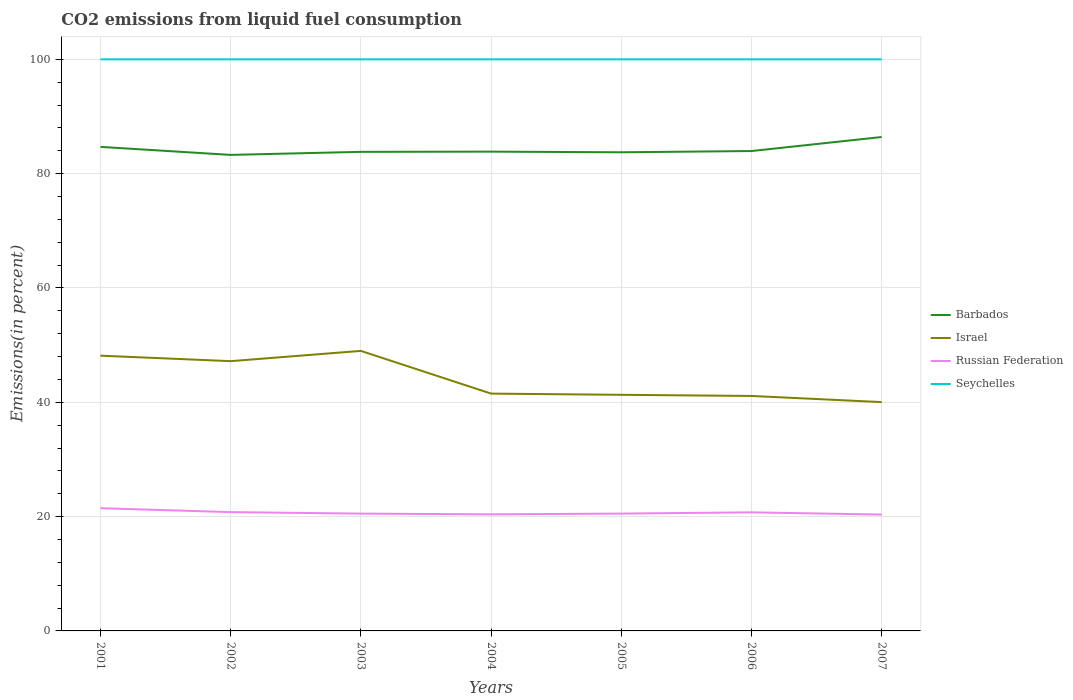Does the line corresponding to Seychelles intersect with the line corresponding to Russian Federation?
Ensure brevity in your answer.  No. Is the number of lines equal to the number of legend labels?
Give a very brief answer. Yes. Across all years, what is the maximum total CO2 emitted in Russian Federation?
Your answer should be very brief. 20.35. What is the total total CO2 emitted in Israel in the graph?
Offer a terse response. 8.12. What is the difference between the highest and the second highest total CO2 emitted in Barbados?
Offer a terse response. 3.13. How many lines are there?
Provide a succinct answer. 4. How many years are there in the graph?
Make the answer very short. 7. Does the graph contain any zero values?
Provide a short and direct response. No. How many legend labels are there?
Keep it short and to the point. 4. What is the title of the graph?
Your answer should be compact. CO2 emissions from liquid fuel consumption. Does "Bangladesh" appear as one of the legend labels in the graph?
Ensure brevity in your answer.  No. What is the label or title of the X-axis?
Give a very brief answer. Years. What is the label or title of the Y-axis?
Your answer should be very brief. Emissions(in percent). What is the Emissions(in percent) in Barbados in 2001?
Give a very brief answer. 84.68. What is the Emissions(in percent) of Israel in 2001?
Offer a terse response. 48.15. What is the Emissions(in percent) of Russian Federation in 2001?
Provide a succinct answer. 21.47. What is the Emissions(in percent) in Seychelles in 2001?
Make the answer very short. 100. What is the Emissions(in percent) in Barbados in 2002?
Give a very brief answer. 83.28. What is the Emissions(in percent) in Israel in 2002?
Ensure brevity in your answer.  47.2. What is the Emissions(in percent) of Russian Federation in 2002?
Offer a terse response. 20.79. What is the Emissions(in percent) of Seychelles in 2002?
Keep it short and to the point. 100. What is the Emissions(in percent) of Barbados in 2003?
Give a very brief answer. 83.82. What is the Emissions(in percent) of Israel in 2003?
Offer a very short reply. 48.99. What is the Emissions(in percent) of Russian Federation in 2003?
Provide a short and direct response. 20.52. What is the Emissions(in percent) of Barbados in 2004?
Provide a short and direct response. 83.85. What is the Emissions(in percent) of Israel in 2004?
Provide a short and direct response. 41.52. What is the Emissions(in percent) in Russian Federation in 2004?
Your answer should be very brief. 20.39. What is the Emissions(in percent) of Seychelles in 2004?
Provide a succinct answer. 100. What is the Emissions(in percent) in Barbados in 2005?
Ensure brevity in your answer.  83.74. What is the Emissions(in percent) in Israel in 2005?
Provide a short and direct response. 41.31. What is the Emissions(in percent) of Russian Federation in 2005?
Your response must be concise. 20.53. What is the Emissions(in percent) of Barbados in 2006?
Provide a succinct answer. 83.96. What is the Emissions(in percent) in Israel in 2006?
Ensure brevity in your answer.  41.11. What is the Emissions(in percent) of Russian Federation in 2006?
Make the answer very short. 20.74. What is the Emissions(in percent) of Seychelles in 2006?
Your response must be concise. 100. What is the Emissions(in percent) in Barbados in 2007?
Your answer should be very brief. 86.41. What is the Emissions(in percent) in Israel in 2007?
Provide a succinct answer. 40.03. What is the Emissions(in percent) of Russian Federation in 2007?
Ensure brevity in your answer.  20.35. What is the Emissions(in percent) of Seychelles in 2007?
Keep it short and to the point. 100. Across all years, what is the maximum Emissions(in percent) of Barbados?
Your answer should be very brief. 86.41. Across all years, what is the maximum Emissions(in percent) in Israel?
Your response must be concise. 48.99. Across all years, what is the maximum Emissions(in percent) of Russian Federation?
Ensure brevity in your answer.  21.47. Across all years, what is the minimum Emissions(in percent) of Barbados?
Make the answer very short. 83.28. Across all years, what is the minimum Emissions(in percent) in Israel?
Make the answer very short. 40.03. Across all years, what is the minimum Emissions(in percent) in Russian Federation?
Your answer should be compact. 20.35. Across all years, what is the minimum Emissions(in percent) of Seychelles?
Give a very brief answer. 100. What is the total Emissions(in percent) in Barbados in the graph?
Keep it short and to the point. 589.74. What is the total Emissions(in percent) of Israel in the graph?
Offer a terse response. 308.31. What is the total Emissions(in percent) in Russian Federation in the graph?
Offer a very short reply. 144.8. What is the total Emissions(in percent) of Seychelles in the graph?
Make the answer very short. 700. What is the difference between the Emissions(in percent) of Barbados in 2001 and that in 2002?
Ensure brevity in your answer.  1.4. What is the difference between the Emissions(in percent) in Israel in 2001 and that in 2002?
Provide a short and direct response. 0.96. What is the difference between the Emissions(in percent) in Russian Federation in 2001 and that in 2002?
Your answer should be compact. 0.68. What is the difference between the Emissions(in percent) of Barbados in 2001 and that in 2003?
Give a very brief answer. 0.87. What is the difference between the Emissions(in percent) in Israel in 2001 and that in 2003?
Your answer should be very brief. -0.84. What is the difference between the Emissions(in percent) in Russian Federation in 2001 and that in 2003?
Provide a succinct answer. 0.95. What is the difference between the Emissions(in percent) in Barbados in 2001 and that in 2004?
Ensure brevity in your answer.  0.83. What is the difference between the Emissions(in percent) in Israel in 2001 and that in 2004?
Provide a succinct answer. 6.64. What is the difference between the Emissions(in percent) of Russian Federation in 2001 and that in 2004?
Provide a short and direct response. 1.08. What is the difference between the Emissions(in percent) in Seychelles in 2001 and that in 2004?
Make the answer very short. 0. What is the difference between the Emissions(in percent) of Barbados in 2001 and that in 2005?
Provide a succinct answer. 0.94. What is the difference between the Emissions(in percent) in Israel in 2001 and that in 2005?
Your answer should be compact. 6.85. What is the difference between the Emissions(in percent) of Russian Federation in 2001 and that in 2005?
Provide a short and direct response. 0.94. What is the difference between the Emissions(in percent) of Seychelles in 2001 and that in 2005?
Your response must be concise. 0. What is the difference between the Emissions(in percent) in Barbados in 2001 and that in 2006?
Provide a short and direct response. 0.73. What is the difference between the Emissions(in percent) in Israel in 2001 and that in 2006?
Keep it short and to the point. 7.05. What is the difference between the Emissions(in percent) in Russian Federation in 2001 and that in 2006?
Give a very brief answer. 0.73. What is the difference between the Emissions(in percent) of Seychelles in 2001 and that in 2006?
Your answer should be compact. 0. What is the difference between the Emissions(in percent) of Barbados in 2001 and that in 2007?
Your answer should be compact. -1.73. What is the difference between the Emissions(in percent) of Israel in 2001 and that in 2007?
Offer a very short reply. 8.12. What is the difference between the Emissions(in percent) of Russian Federation in 2001 and that in 2007?
Your answer should be compact. 1.12. What is the difference between the Emissions(in percent) in Barbados in 2002 and that in 2003?
Your response must be concise. -0.53. What is the difference between the Emissions(in percent) of Israel in 2002 and that in 2003?
Provide a succinct answer. -1.8. What is the difference between the Emissions(in percent) in Russian Federation in 2002 and that in 2003?
Ensure brevity in your answer.  0.27. What is the difference between the Emissions(in percent) of Seychelles in 2002 and that in 2003?
Your response must be concise. 0. What is the difference between the Emissions(in percent) of Barbados in 2002 and that in 2004?
Offer a very short reply. -0.57. What is the difference between the Emissions(in percent) of Israel in 2002 and that in 2004?
Your response must be concise. 5.68. What is the difference between the Emissions(in percent) in Russian Federation in 2002 and that in 2004?
Provide a succinct answer. 0.39. What is the difference between the Emissions(in percent) of Seychelles in 2002 and that in 2004?
Offer a terse response. 0. What is the difference between the Emissions(in percent) of Barbados in 2002 and that in 2005?
Provide a succinct answer. -0.46. What is the difference between the Emissions(in percent) in Israel in 2002 and that in 2005?
Provide a succinct answer. 5.89. What is the difference between the Emissions(in percent) of Russian Federation in 2002 and that in 2005?
Give a very brief answer. 0.26. What is the difference between the Emissions(in percent) in Seychelles in 2002 and that in 2005?
Your answer should be compact. 0. What is the difference between the Emissions(in percent) in Barbados in 2002 and that in 2006?
Keep it short and to the point. -0.67. What is the difference between the Emissions(in percent) in Israel in 2002 and that in 2006?
Your response must be concise. 6.09. What is the difference between the Emissions(in percent) in Russian Federation in 2002 and that in 2006?
Keep it short and to the point. 0.04. What is the difference between the Emissions(in percent) in Seychelles in 2002 and that in 2006?
Give a very brief answer. 0. What is the difference between the Emissions(in percent) in Barbados in 2002 and that in 2007?
Make the answer very short. -3.13. What is the difference between the Emissions(in percent) in Israel in 2002 and that in 2007?
Offer a terse response. 7.16. What is the difference between the Emissions(in percent) of Russian Federation in 2002 and that in 2007?
Offer a very short reply. 0.43. What is the difference between the Emissions(in percent) of Seychelles in 2002 and that in 2007?
Make the answer very short. 0. What is the difference between the Emissions(in percent) in Barbados in 2003 and that in 2004?
Your response must be concise. -0.04. What is the difference between the Emissions(in percent) in Israel in 2003 and that in 2004?
Provide a short and direct response. 7.47. What is the difference between the Emissions(in percent) of Russian Federation in 2003 and that in 2004?
Provide a short and direct response. 0.13. What is the difference between the Emissions(in percent) in Seychelles in 2003 and that in 2004?
Keep it short and to the point. 0. What is the difference between the Emissions(in percent) of Barbados in 2003 and that in 2005?
Provide a succinct answer. 0.08. What is the difference between the Emissions(in percent) of Israel in 2003 and that in 2005?
Your answer should be compact. 7.68. What is the difference between the Emissions(in percent) of Russian Federation in 2003 and that in 2005?
Your answer should be compact. -0.01. What is the difference between the Emissions(in percent) in Seychelles in 2003 and that in 2005?
Your answer should be very brief. 0. What is the difference between the Emissions(in percent) in Barbados in 2003 and that in 2006?
Your answer should be very brief. -0.14. What is the difference between the Emissions(in percent) in Israel in 2003 and that in 2006?
Make the answer very short. 7.88. What is the difference between the Emissions(in percent) in Russian Federation in 2003 and that in 2006?
Give a very brief answer. -0.22. What is the difference between the Emissions(in percent) in Seychelles in 2003 and that in 2006?
Your response must be concise. 0. What is the difference between the Emissions(in percent) of Barbados in 2003 and that in 2007?
Give a very brief answer. -2.6. What is the difference between the Emissions(in percent) of Israel in 2003 and that in 2007?
Your answer should be compact. 8.96. What is the difference between the Emissions(in percent) of Russian Federation in 2003 and that in 2007?
Offer a terse response. 0.17. What is the difference between the Emissions(in percent) in Seychelles in 2003 and that in 2007?
Your answer should be compact. 0. What is the difference between the Emissions(in percent) of Barbados in 2004 and that in 2005?
Provide a short and direct response. 0.11. What is the difference between the Emissions(in percent) of Israel in 2004 and that in 2005?
Ensure brevity in your answer.  0.21. What is the difference between the Emissions(in percent) in Russian Federation in 2004 and that in 2005?
Make the answer very short. -0.13. What is the difference between the Emissions(in percent) in Barbados in 2004 and that in 2006?
Your answer should be compact. -0.1. What is the difference between the Emissions(in percent) in Israel in 2004 and that in 2006?
Provide a short and direct response. 0.41. What is the difference between the Emissions(in percent) in Russian Federation in 2004 and that in 2006?
Ensure brevity in your answer.  -0.35. What is the difference between the Emissions(in percent) of Barbados in 2004 and that in 2007?
Give a very brief answer. -2.56. What is the difference between the Emissions(in percent) in Israel in 2004 and that in 2007?
Provide a succinct answer. 1.49. What is the difference between the Emissions(in percent) in Russian Federation in 2004 and that in 2007?
Keep it short and to the point. 0.04. What is the difference between the Emissions(in percent) in Seychelles in 2004 and that in 2007?
Ensure brevity in your answer.  0. What is the difference between the Emissions(in percent) of Barbados in 2005 and that in 2006?
Give a very brief answer. -0.22. What is the difference between the Emissions(in percent) in Israel in 2005 and that in 2006?
Your answer should be very brief. 0.2. What is the difference between the Emissions(in percent) in Russian Federation in 2005 and that in 2006?
Offer a terse response. -0.22. What is the difference between the Emissions(in percent) of Seychelles in 2005 and that in 2006?
Keep it short and to the point. 0. What is the difference between the Emissions(in percent) of Barbados in 2005 and that in 2007?
Provide a succinct answer. -2.67. What is the difference between the Emissions(in percent) in Israel in 2005 and that in 2007?
Your answer should be very brief. 1.27. What is the difference between the Emissions(in percent) of Russian Federation in 2005 and that in 2007?
Your answer should be compact. 0.17. What is the difference between the Emissions(in percent) in Seychelles in 2005 and that in 2007?
Make the answer very short. 0. What is the difference between the Emissions(in percent) of Barbados in 2006 and that in 2007?
Make the answer very short. -2.45. What is the difference between the Emissions(in percent) in Israel in 2006 and that in 2007?
Your answer should be very brief. 1.07. What is the difference between the Emissions(in percent) of Russian Federation in 2006 and that in 2007?
Ensure brevity in your answer.  0.39. What is the difference between the Emissions(in percent) in Seychelles in 2006 and that in 2007?
Provide a succinct answer. 0. What is the difference between the Emissions(in percent) of Barbados in 2001 and the Emissions(in percent) of Israel in 2002?
Provide a short and direct response. 37.49. What is the difference between the Emissions(in percent) of Barbados in 2001 and the Emissions(in percent) of Russian Federation in 2002?
Give a very brief answer. 63.9. What is the difference between the Emissions(in percent) in Barbados in 2001 and the Emissions(in percent) in Seychelles in 2002?
Your answer should be very brief. -15.32. What is the difference between the Emissions(in percent) in Israel in 2001 and the Emissions(in percent) in Russian Federation in 2002?
Your answer should be compact. 27.37. What is the difference between the Emissions(in percent) in Israel in 2001 and the Emissions(in percent) in Seychelles in 2002?
Provide a short and direct response. -51.84. What is the difference between the Emissions(in percent) in Russian Federation in 2001 and the Emissions(in percent) in Seychelles in 2002?
Ensure brevity in your answer.  -78.53. What is the difference between the Emissions(in percent) of Barbados in 2001 and the Emissions(in percent) of Israel in 2003?
Provide a succinct answer. 35.69. What is the difference between the Emissions(in percent) in Barbados in 2001 and the Emissions(in percent) in Russian Federation in 2003?
Offer a very short reply. 64.16. What is the difference between the Emissions(in percent) in Barbados in 2001 and the Emissions(in percent) in Seychelles in 2003?
Keep it short and to the point. -15.32. What is the difference between the Emissions(in percent) in Israel in 2001 and the Emissions(in percent) in Russian Federation in 2003?
Make the answer very short. 27.63. What is the difference between the Emissions(in percent) in Israel in 2001 and the Emissions(in percent) in Seychelles in 2003?
Keep it short and to the point. -51.84. What is the difference between the Emissions(in percent) of Russian Federation in 2001 and the Emissions(in percent) of Seychelles in 2003?
Make the answer very short. -78.53. What is the difference between the Emissions(in percent) in Barbados in 2001 and the Emissions(in percent) in Israel in 2004?
Your answer should be very brief. 43.17. What is the difference between the Emissions(in percent) in Barbados in 2001 and the Emissions(in percent) in Russian Federation in 2004?
Keep it short and to the point. 64.29. What is the difference between the Emissions(in percent) in Barbados in 2001 and the Emissions(in percent) in Seychelles in 2004?
Offer a very short reply. -15.32. What is the difference between the Emissions(in percent) in Israel in 2001 and the Emissions(in percent) in Russian Federation in 2004?
Make the answer very short. 27.76. What is the difference between the Emissions(in percent) in Israel in 2001 and the Emissions(in percent) in Seychelles in 2004?
Give a very brief answer. -51.84. What is the difference between the Emissions(in percent) in Russian Federation in 2001 and the Emissions(in percent) in Seychelles in 2004?
Keep it short and to the point. -78.53. What is the difference between the Emissions(in percent) of Barbados in 2001 and the Emissions(in percent) of Israel in 2005?
Ensure brevity in your answer.  43.38. What is the difference between the Emissions(in percent) in Barbados in 2001 and the Emissions(in percent) in Russian Federation in 2005?
Provide a short and direct response. 64.16. What is the difference between the Emissions(in percent) of Barbados in 2001 and the Emissions(in percent) of Seychelles in 2005?
Give a very brief answer. -15.32. What is the difference between the Emissions(in percent) of Israel in 2001 and the Emissions(in percent) of Russian Federation in 2005?
Your answer should be very brief. 27.63. What is the difference between the Emissions(in percent) of Israel in 2001 and the Emissions(in percent) of Seychelles in 2005?
Give a very brief answer. -51.84. What is the difference between the Emissions(in percent) of Russian Federation in 2001 and the Emissions(in percent) of Seychelles in 2005?
Offer a very short reply. -78.53. What is the difference between the Emissions(in percent) in Barbados in 2001 and the Emissions(in percent) in Israel in 2006?
Provide a short and direct response. 43.58. What is the difference between the Emissions(in percent) of Barbados in 2001 and the Emissions(in percent) of Russian Federation in 2006?
Offer a very short reply. 63.94. What is the difference between the Emissions(in percent) of Barbados in 2001 and the Emissions(in percent) of Seychelles in 2006?
Ensure brevity in your answer.  -15.32. What is the difference between the Emissions(in percent) of Israel in 2001 and the Emissions(in percent) of Russian Federation in 2006?
Make the answer very short. 27.41. What is the difference between the Emissions(in percent) in Israel in 2001 and the Emissions(in percent) in Seychelles in 2006?
Make the answer very short. -51.84. What is the difference between the Emissions(in percent) in Russian Federation in 2001 and the Emissions(in percent) in Seychelles in 2006?
Offer a terse response. -78.53. What is the difference between the Emissions(in percent) in Barbados in 2001 and the Emissions(in percent) in Israel in 2007?
Your answer should be compact. 44.65. What is the difference between the Emissions(in percent) in Barbados in 2001 and the Emissions(in percent) in Russian Federation in 2007?
Offer a very short reply. 64.33. What is the difference between the Emissions(in percent) in Barbados in 2001 and the Emissions(in percent) in Seychelles in 2007?
Keep it short and to the point. -15.32. What is the difference between the Emissions(in percent) in Israel in 2001 and the Emissions(in percent) in Russian Federation in 2007?
Provide a short and direct response. 27.8. What is the difference between the Emissions(in percent) of Israel in 2001 and the Emissions(in percent) of Seychelles in 2007?
Offer a terse response. -51.84. What is the difference between the Emissions(in percent) of Russian Federation in 2001 and the Emissions(in percent) of Seychelles in 2007?
Provide a succinct answer. -78.53. What is the difference between the Emissions(in percent) in Barbados in 2002 and the Emissions(in percent) in Israel in 2003?
Provide a succinct answer. 34.29. What is the difference between the Emissions(in percent) in Barbados in 2002 and the Emissions(in percent) in Russian Federation in 2003?
Provide a succinct answer. 62.76. What is the difference between the Emissions(in percent) in Barbados in 2002 and the Emissions(in percent) in Seychelles in 2003?
Provide a succinct answer. -16.72. What is the difference between the Emissions(in percent) of Israel in 2002 and the Emissions(in percent) of Russian Federation in 2003?
Your answer should be very brief. 26.67. What is the difference between the Emissions(in percent) in Israel in 2002 and the Emissions(in percent) in Seychelles in 2003?
Keep it short and to the point. -52.8. What is the difference between the Emissions(in percent) in Russian Federation in 2002 and the Emissions(in percent) in Seychelles in 2003?
Make the answer very short. -79.21. What is the difference between the Emissions(in percent) in Barbados in 2002 and the Emissions(in percent) in Israel in 2004?
Ensure brevity in your answer.  41.76. What is the difference between the Emissions(in percent) in Barbados in 2002 and the Emissions(in percent) in Russian Federation in 2004?
Ensure brevity in your answer.  62.89. What is the difference between the Emissions(in percent) of Barbados in 2002 and the Emissions(in percent) of Seychelles in 2004?
Your response must be concise. -16.72. What is the difference between the Emissions(in percent) of Israel in 2002 and the Emissions(in percent) of Russian Federation in 2004?
Keep it short and to the point. 26.8. What is the difference between the Emissions(in percent) in Israel in 2002 and the Emissions(in percent) in Seychelles in 2004?
Offer a very short reply. -52.8. What is the difference between the Emissions(in percent) in Russian Federation in 2002 and the Emissions(in percent) in Seychelles in 2004?
Give a very brief answer. -79.21. What is the difference between the Emissions(in percent) in Barbados in 2002 and the Emissions(in percent) in Israel in 2005?
Keep it short and to the point. 41.98. What is the difference between the Emissions(in percent) of Barbados in 2002 and the Emissions(in percent) of Russian Federation in 2005?
Make the answer very short. 62.76. What is the difference between the Emissions(in percent) in Barbados in 2002 and the Emissions(in percent) in Seychelles in 2005?
Your answer should be very brief. -16.72. What is the difference between the Emissions(in percent) in Israel in 2002 and the Emissions(in percent) in Russian Federation in 2005?
Offer a terse response. 26.67. What is the difference between the Emissions(in percent) of Israel in 2002 and the Emissions(in percent) of Seychelles in 2005?
Offer a very short reply. -52.8. What is the difference between the Emissions(in percent) in Russian Federation in 2002 and the Emissions(in percent) in Seychelles in 2005?
Make the answer very short. -79.21. What is the difference between the Emissions(in percent) of Barbados in 2002 and the Emissions(in percent) of Israel in 2006?
Give a very brief answer. 42.17. What is the difference between the Emissions(in percent) in Barbados in 2002 and the Emissions(in percent) in Russian Federation in 2006?
Your response must be concise. 62.54. What is the difference between the Emissions(in percent) of Barbados in 2002 and the Emissions(in percent) of Seychelles in 2006?
Your answer should be very brief. -16.72. What is the difference between the Emissions(in percent) in Israel in 2002 and the Emissions(in percent) in Russian Federation in 2006?
Ensure brevity in your answer.  26.45. What is the difference between the Emissions(in percent) of Israel in 2002 and the Emissions(in percent) of Seychelles in 2006?
Keep it short and to the point. -52.8. What is the difference between the Emissions(in percent) of Russian Federation in 2002 and the Emissions(in percent) of Seychelles in 2006?
Offer a terse response. -79.21. What is the difference between the Emissions(in percent) in Barbados in 2002 and the Emissions(in percent) in Israel in 2007?
Give a very brief answer. 43.25. What is the difference between the Emissions(in percent) of Barbados in 2002 and the Emissions(in percent) of Russian Federation in 2007?
Offer a very short reply. 62.93. What is the difference between the Emissions(in percent) in Barbados in 2002 and the Emissions(in percent) in Seychelles in 2007?
Your answer should be very brief. -16.72. What is the difference between the Emissions(in percent) of Israel in 2002 and the Emissions(in percent) of Russian Federation in 2007?
Keep it short and to the point. 26.84. What is the difference between the Emissions(in percent) of Israel in 2002 and the Emissions(in percent) of Seychelles in 2007?
Offer a very short reply. -52.8. What is the difference between the Emissions(in percent) in Russian Federation in 2002 and the Emissions(in percent) in Seychelles in 2007?
Ensure brevity in your answer.  -79.21. What is the difference between the Emissions(in percent) of Barbados in 2003 and the Emissions(in percent) of Israel in 2004?
Provide a short and direct response. 42.3. What is the difference between the Emissions(in percent) in Barbados in 2003 and the Emissions(in percent) in Russian Federation in 2004?
Ensure brevity in your answer.  63.42. What is the difference between the Emissions(in percent) of Barbados in 2003 and the Emissions(in percent) of Seychelles in 2004?
Provide a short and direct response. -16.18. What is the difference between the Emissions(in percent) in Israel in 2003 and the Emissions(in percent) in Russian Federation in 2004?
Your answer should be very brief. 28.6. What is the difference between the Emissions(in percent) of Israel in 2003 and the Emissions(in percent) of Seychelles in 2004?
Your answer should be compact. -51.01. What is the difference between the Emissions(in percent) in Russian Federation in 2003 and the Emissions(in percent) in Seychelles in 2004?
Keep it short and to the point. -79.48. What is the difference between the Emissions(in percent) of Barbados in 2003 and the Emissions(in percent) of Israel in 2005?
Make the answer very short. 42.51. What is the difference between the Emissions(in percent) in Barbados in 2003 and the Emissions(in percent) in Russian Federation in 2005?
Your response must be concise. 63.29. What is the difference between the Emissions(in percent) in Barbados in 2003 and the Emissions(in percent) in Seychelles in 2005?
Your response must be concise. -16.18. What is the difference between the Emissions(in percent) of Israel in 2003 and the Emissions(in percent) of Russian Federation in 2005?
Offer a very short reply. 28.46. What is the difference between the Emissions(in percent) of Israel in 2003 and the Emissions(in percent) of Seychelles in 2005?
Provide a short and direct response. -51.01. What is the difference between the Emissions(in percent) in Russian Federation in 2003 and the Emissions(in percent) in Seychelles in 2005?
Offer a very short reply. -79.48. What is the difference between the Emissions(in percent) of Barbados in 2003 and the Emissions(in percent) of Israel in 2006?
Make the answer very short. 42.71. What is the difference between the Emissions(in percent) in Barbados in 2003 and the Emissions(in percent) in Russian Federation in 2006?
Offer a terse response. 63.07. What is the difference between the Emissions(in percent) of Barbados in 2003 and the Emissions(in percent) of Seychelles in 2006?
Provide a succinct answer. -16.18. What is the difference between the Emissions(in percent) in Israel in 2003 and the Emissions(in percent) in Russian Federation in 2006?
Provide a short and direct response. 28.25. What is the difference between the Emissions(in percent) in Israel in 2003 and the Emissions(in percent) in Seychelles in 2006?
Your answer should be very brief. -51.01. What is the difference between the Emissions(in percent) of Russian Federation in 2003 and the Emissions(in percent) of Seychelles in 2006?
Offer a very short reply. -79.48. What is the difference between the Emissions(in percent) in Barbados in 2003 and the Emissions(in percent) in Israel in 2007?
Your answer should be very brief. 43.78. What is the difference between the Emissions(in percent) of Barbados in 2003 and the Emissions(in percent) of Russian Federation in 2007?
Your answer should be compact. 63.46. What is the difference between the Emissions(in percent) in Barbados in 2003 and the Emissions(in percent) in Seychelles in 2007?
Your response must be concise. -16.18. What is the difference between the Emissions(in percent) in Israel in 2003 and the Emissions(in percent) in Russian Federation in 2007?
Provide a short and direct response. 28.64. What is the difference between the Emissions(in percent) of Israel in 2003 and the Emissions(in percent) of Seychelles in 2007?
Your answer should be compact. -51.01. What is the difference between the Emissions(in percent) in Russian Federation in 2003 and the Emissions(in percent) in Seychelles in 2007?
Your response must be concise. -79.48. What is the difference between the Emissions(in percent) of Barbados in 2004 and the Emissions(in percent) of Israel in 2005?
Offer a terse response. 42.55. What is the difference between the Emissions(in percent) of Barbados in 2004 and the Emissions(in percent) of Russian Federation in 2005?
Provide a succinct answer. 63.33. What is the difference between the Emissions(in percent) in Barbados in 2004 and the Emissions(in percent) in Seychelles in 2005?
Your response must be concise. -16.15. What is the difference between the Emissions(in percent) in Israel in 2004 and the Emissions(in percent) in Russian Federation in 2005?
Ensure brevity in your answer.  20.99. What is the difference between the Emissions(in percent) in Israel in 2004 and the Emissions(in percent) in Seychelles in 2005?
Offer a terse response. -58.48. What is the difference between the Emissions(in percent) in Russian Federation in 2004 and the Emissions(in percent) in Seychelles in 2005?
Provide a short and direct response. -79.61. What is the difference between the Emissions(in percent) of Barbados in 2004 and the Emissions(in percent) of Israel in 2006?
Make the answer very short. 42.74. What is the difference between the Emissions(in percent) in Barbados in 2004 and the Emissions(in percent) in Russian Federation in 2006?
Your answer should be very brief. 63.11. What is the difference between the Emissions(in percent) of Barbados in 2004 and the Emissions(in percent) of Seychelles in 2006?
Your answer should be compact. -16.15. What is the difference between the Emissions(in percent) in Israel in 2004 and the Emissions(in percent) in Russian Federation in 2006?
Offer a terse response. 20.78. What is the difference between the Emissions(in percent) in Israel in 2004 and the Emissions(in percent) in Seychelles in 2006?
Your response must be concise. -58.48. What is the difference between the Emissions(in percent) of Russian Federation in 2004 and the Emissions(in percent) of Seychelles in 2006?
Provide a short and direct response. -79.61. What is the difference between the Emissions(in percent) in Barbados in 2004 and the Emissions(in percent) in Israel in 2007?
Offer a very short reply. 43.82. What is the difference between the Emissions(in percent) of Barbados in 2004 and the Emissions(in percent) of Russian Federation in 2007?
Provide a short and direct response. 63.5. What is the difference between the Emissions(in percent) of Barbados in 2004 and the Emissions(in percent) of Seychelles in 2007?
Offer a terse response. -16.15. What is the difference between the Emissions(in percent) in Israel in 2004 and the Emissions(in percent) in Russian Federation in 2007?
Ensure brevity in your answer.  21.17. What is the difference between the Emissions(in percent) in Israel in 2004 and the Emissions(in percent) in Seychelles in 2007?
Keep it short and to the point. -58.48. What is the difference between the Emissions(in percent) of Russian Federation in 2004 and the Emissions(in percent) of Seychelles in 2007?
Offer a very short reply. -79.61. What is the difference between the Emissions(in percent) in Barbados in 2005 and the Emissions(in percent) in Israel in 2006?
Make the answer very short. 42.63. What is the difference between the Emissions(in percent) of Barbados in 2005 and the Emissions(in percent) of Russian Federation in 2006?
Make the answer very short. 63. What is the difference between the Emissions(in percent) of Barbados in 2005 and the Emissions(in percent) of Seychelles in 2006?
Ensure brevity in your answer.  -16.26. What is the difference between the Emissions(in percent) in Israel in 2005 and the Emissions(in percent) in Russian Federation in 2006?
Offer a terse response. 20.56. What is the difference between the Emissions(in percent) in Israel in 2005 and the Emissions(in percent) in Seychelles in 2006?
Your answer should be very brief. -58.69. What is the difference between the Emissions(in percent) of Russian Federation in 2005 and the Emissions(in percent) of Seychelles in 2006?
Your answer should be compact. -79.47. What is the difference between the Emissions(in percent) in Barbados in 2005 and the Emissions(in percent) in Israel in 2007?
Provide a short and direct response. 43.71. What is the difference between the Emissions(in percent) of Barbados in 2005 and the Emissions(in percent) of Russian Federation in 2007?
Your response must be concise. 63.39. What is the difference between the Emissions(in percent) of Barbados in 2005 and the Emissions(in percent) of Seychelles in 2007?
Make the answer very short. -16.26. What is the difference between the Emissions(in percent) of Israel in 2005 and the Emissions(in percent) of Russian Federation in 2007?
Your response must be concise. 20.95. What is the difference between the Emissions(in percent) in Israel in 2005 and the Emissions(in percent) in Seychelles in 2007?
Provide a short and direct response. -58.69. What is the difference between the Emissions(in percent) of Russian Federation in 2005 and the Emissions(in percent) of Seychelles in 2007?
Make the answer very short. -79.47. What is the difference between the Emissions(in percent) of Barbados in 2006 and the Emissions(in percent) of Israel in 2007?
Your answer should be very brief. 43.92. What is the difference between the Emissions(in percent) of Barbados in 2006 and the Emissions(in percent) of Russian Federation in 2007?
Your answer should be compact. 63.6. What is the difference between the Emissions(in percent) of Barbados in 2006 and the Emissions(in percent) of Seychelles in 2007?
Ensure brevity in your answer.  -16.04. What is the difference between the Emissions(in percent) of Israel in 2006 and the Emissions(in percent) of Russian Federation in 2007?
Your response must be concise. 20.75. What is the difference between the Emissions(in percent) in Israel in 2006 and the Emissions(in percent) in Seychelles in 2007?
Offer a terse response. -58.89. What is the difference between the Emissions(in percent) of Russian Federation in 2006 and the Emissions(in percent) of Seychelles in 2007?
Your answer should be very brief. -79.26. What is the average Emissions(in percent) in Barbados per year?
Ensure brevity in your answer.  84.25. What is the average Emissions(in percent) of Israel per year?
Your response must be concise. 44.04. What is the average Emissions(in percent) of Russian Federation per year?
Offer a terse response. 20.69. In the year 2001, what is the difference between the Emissions(in percent) in Barbados and Emissions(in percent) in Israel?
Keep it short and to the point. 36.53. In the year 2001, what is the difference between the Emissions(in percent) of Barbados and Emissions(in percent) of Russian Federation?
Make the answer very short. 63.21. In the year 2001, what is the difference between the Emissions(in percent) in Barbados and Emissions(in percent) in Seychelles?
Provide a succinct answer. -15.32. In the year 2001, what is the difference between the Emissions(in percent) in Israel and Emissions(in percent) in Russian Federation?
Your answer should be compact. 26.68. In the year 2001, what is the difference between the Emissions(in percent) of Israel and Emissions(in percent) of Seychelles?
Give a very brief answer. -51.84. In the year 2001, what is the difference between the Emissions(in percent) of Russian Federation and Emissions(in percent) of Seychelles?
Keep it short and to the point. -78.53. In the year 2002, what is the difference between the Emissions(in percent) in Barbados and Emissions(in percent) in Israel?
Offer a very short reply. 36.09. In the year 2002, what is the difference between the Emissions(in percent) in Barbados and Emissions(in percent) in Russian Federation?
Provide a succinct answer. 62.5. In the year 2002, what is the difference between the Emissions(in percent) of Barbados and Emissions(in percent) of Seychelles?
Keep it short and to the point. -16.72. In the year 2002, what is the difference between the Emissions(in percent) in Israel and Emissions(in percent) in Russian Federation?
Your answer should be compact. 26.41. In the year 2002, what is the difference between the Emissions(in percent) of Israel and Emissions(in percent) of Seychelles?
Your response must be concise. -52.8. In the year 2002, what is the difference between the Emissions(in percent) of Russian Federation and Emissions(in percent) of Seychelles?
Your answer should be very brief. -79.21. In the year 2003, what is the difference between the Emissions(in percent) in Barbados and Emissions(in percent) in Israel?
Give a very brief answer. 34.82. In the year 2003, what is the difference between the Emissions(in percent) of Barbados and Emissions(in percent) of Russian Federation?
Give a very brief answer. 63.29. In the year 2003, what is the difference between the Emissions(in percent) of Barbados and Emissions(in percent) of Seychelles?
Keep it short and to the point. -16.18. In the year 2003, what is the difference between the Emissions(in percent) of Israel and Emissions(in percent) of Russian Federation?
Provide a short and direct response. 28.47. In the year 2003, what is the difference between the Emissions(in percent) of Israel and Emissions(in percent) of Seychelles?
Provide a short and direct response. -51.01. In the year 2003, what is the difference between the Emissions(in percent) in Russian Federation and Emissions(in percent) in Seychelles?
Make the answer very short. -79.48. In the year 2004, what is the difference between the Emissions(in percent) of Barbados and Emissions(in percent) of Israel?
Ensure brevity in your answer.  42.33. In the year 2004, what is the difference between the Emissions(in percent) in Barbados and Emissions(in percent) in Russian Federation?
Provide a short and direct response. 63.46. In the year 2004, what is the difference between the Emissions(in percent) of Barbados and Emissions(in percent) of Seychelles?
Make the answer very short. -16.15. In the year 2004, what is the difference between the Emissions(in percent) of Israel and Emissions(in percent) of Russian Federation?
Keep it short and to the point. 21.12. In the year 2004, what is the difference between the Emissions(in percent) in Israel and Emissions(in percent) in Seychelles?
Provide a short and direct response. -58.48. In the year 2004, what is the difference between the Emissions(in percent) of Russian Federation and Emissions(in percent) of Seychelles?
Your response must be concise. -79.61. In the year 2005, what is the difference between the Emissions(in percent) in Barbados and Emissions(in percent) in Israel?
Ensure brevity in your answer.  42.43. In the year 2005, what is the difference between the Emissions(in percent) in Barbados and Emissions(in percent) in Russian Federation?
Provide a succinct answer. 63.21. In the year 2005, what is the difference between the Emissions(in percent) of Barbados and Emissions(in percent) of Seychelles?
Offer a terse response. -16.26. In the year 2005, what is the difference between the Emissions(in percent) of Israel and Emissions(in percent) of Russian Federation?
Make the answer very short. 20.78. In the year 2005, what is the difference between the Emissions(in percent) of Israel and Emissions(in percent) of Seychelles?
Your response must be concise. -58.69. In the year 2005, what is the difference between the Emissions(in percent) in Russian Federation and Emissions(in percent) in Seychelles?
Ensure brevity in your answer.  -79.47. In the year 2006, what is the difference between the Emissions(in percent) in Barbados and Emissions(in percent) in Israel?
Make the answer very short. 42.85. In the year 2006, what is the difference between the Emissions(in percent) in Barbados and Emissions(in percent) in Russian Federation?
Provide a short and direct response. 63.21. In the year 2006, what is the difference between the Emissions(in percent) in Barbados and Emissions(in percent) in Seychelles?
Provide a short and direct response. -16.04. In the year 2006, what is the difference between the Emissions(in percent) in Israel and Emissions(in percent) in Russian Federation?
Provide a succinct answer. 20.36. In the year 2006, what is the difference between the Emissions(in percent) in Israel and Emissions(in percent) in Seychelles?
Ensure brevity in your answer.  -58.89. In the year 2006, what is the difference between the Emissions(in percent) of Russian Federation and Emissions(in percent) of Seychelles?
Your answer should be compact. -79.26. In the year 2007, what is the difference between the Emissions(in percent) of Barbados and Emissions(in percent) of Israel?
Your answer should be very brief. 46.38. In the year 2007, what is the difference between the Emissions(in percent) in Barbados and Emissions(in percent) in Russian Federation?
Keep it short and to the point. 66.06. In the year 2007, what is the difference between the Emissions(in percent) in Barbados and Emissions(in percent) in Seychelles?
Offer a terse response. -13.59. In the year 2007, what is the difference between the Emissions(in percent) of Israel and Emissions(in percent) of Russian Federation?
Your answer should be very brief. 19.68. In the year 2007, what is the difference between the Emissions(in percent) of Israel and Emissions(in percent) of Seychelles?
Provide a succinct answer. -59.97. In the year 2007, what is the difference between the Emissions(in percent) of Russian Federation and Emissions(in percent) of Seychelles?
Offer a very short reply. -79.65. What is the ratio of the Emissions(in percent) in Barbados in 2001 to that in 2002?
Keep it short and to the point. 1.02. What is the ratio of the Emissions(in percent) in Israel in 2001 to that in 2002?
Keep it short and to the point. 1.02. What is the ratio of the Emissions(in percent) of Russian Federation in 2001 to that in 2002?
Offer a terse response. 1.03. What is the ratio of the Emissions(in percent) of Barbados in 2001 to that in 2003?
Ensure brevity in your answer.  1.01. What is the ratio of the Emissions(in percent) of Israel in 2001 to that in 2003?
Your response must be concise. 0.98. What is the ratio of the Emissions(in percent) of Russian Federation in 2001 to that in 2003?
Keep it short and to the point. 1.05. What is the ratio of the Emissions(in percent) in Barbados in 2001 to that in 2004?
Your response must be concise. 1.01. What is the ratio of the Emissions(in percent) in Israel in 2001 to that in 2004?
Provide a short and direct response. 1.16. What is the ratio of the Emissions(in percent) in Russian Federation in 2001 to that in 2004?
Provide a succinct answer. 1.05. What is the ratio of the Emissions(in percent) of Barbados in 2001 to that in 2005?
Offer a terse response. 1.01. What is the ratio of the Emissions(in percent) of Israel in 2001 to that in 2005?
Provide a short and direct response. 1.17. What is the ratio of the Emissions(in percent) in Russian Federation in 2001 to that in 2005?
Provide a succinct answer. 1.05. What is the ratio of the Emissions(in percent) in Barbados in 2001 to that in 2006?
Provide a short and direct response. 1.01. What is the ratio of the Emissions(in percent) in Israel in 2001 to that in 2006?
Your answer should be very brief. 1.17. What is the ratio of the Emissions(in percent) of Russian Federation in 2001 to that in 2006?
Keep it short and to the point. 1.03. What is the ratio of the Emissions(in percent) in Barbados in 2001 to that in 2007?
Ensure brevity in your answer.  0.98. What is the ratio of the Emissions(in percent) in Israel in 2001 to that in 2007?
Your answer should be compact. 1.2. What is the ratio of the Emissions(in percent) of Russian Federation in 2001 to that in 2007?
Your answer should be very brief. 1.05. What is the ratio of the Emissions(in percent) of Israel in 2002 to that in 2003?
Provide a succinct answer. 0.96. What is the ratio of the Emissions(in percent) in Russian Federation in 2002 to that in 2003?
Offer a very short reply. 1.01. What is the ratio of the Emissions(in percent) of Barbados in 2002 to that in 2004?
Offer a terse response. 0.99. What is the ratio of the Emissions(in percent) in Israel in 2002 to that in 2004?
Provide a short and direct response. 1.14. What is the ratio of the Emissions(in percent) in Russian Federation in 2002 to that in 2004?
Offer a very short reply. 1.02. What is the ratio of the Emissions(in percent) in Barbados in 2002 to that in 2005?
Provide a succinct answer. 0.99. What is the ratio of the Emissions(in percent) in Israel in 2002 to that in 2005?
Ensure brevity in your answer.  1.14. What is the ratio of the Emissions(in percent) of Russian Federation in 2002 to that in 2005?
Keep it short and to the point. 1.01. What is the ratio of the Emissions(in percent) in Seychelles in 2002 to that in 2005?
Provide a succinct answer. 1. What is the ratio of the Emissions(in percent) of Barbados in 2002 to that in 2006?
Keep it short and to the point. 0.99. What is the ratio of the Emissions(in percent) of Israel in 2002 to that in 2006?
Ensure brevity in your answer.  1.15. What is the ratio of the Emissions(in percent) in Seychelles in 2002 to that in 2006?
Offer a very short reply. 1. What is the ratio of the Emissions(in percent) of Barbados in 2002 to that in 2007?
Provide a succinct answer. 0.96. What is the ratio of the Emissions(in percent) in Israel in 2002 to that in 2007?
Ensure brevity in your answer.  1.18. What is the ratio of the Emissions(in percent) in Russian Federation in 2002 to that in 2007?
Your answer should be very brief. 1.02. What is the ratio of the Emissions(in percent) in Seychelles in 2002 to that in 2007?
Your answer should be compact. 1. What is the ratio of the Emissions(in percent) in Barbados in 2003 to that in 2004?
Make the answer very short. 1. What is the ratio of the Emissions(in percent) of Israel in 2003 to that in 2004?
Offer a terse response. 1.18. What is the ratio of the Emissions(in percent) in Barbados in 2003 to that in 2005?
Your answer should be compact. 1. What is the ratio of the Emissions(in percent) in Israel in 2003 to that in 2005?
Your answer should be very brief. 1.19. What is the ratio of the Emissions(in percent) of Barbados in 2003 to that in 2006?
Make the answer very short. 1. What is the ratio of the Emissions(in percent) of Israel in 2003 to that in 2006?
Ensure brevity in your answer.  1.19. What is the ratio of the Emissions(in percent) in Russian Federation in 2003 to that in 2006?
Your response must be concise. 0.99. What is the ratio of the Emissions(in percent) of Seychelles in 2003 to that in 2006?
Provide a succinct answer. 1. What is the ratio of the Emissions(in percent) of Barbados in 2003 to that in 2007?
Offer a terse response. 0.97. What is the ratio of the Emissions(in percent) in Israel in 2003 to that in 2007?
Provide a succinct answer. 1.22. What is the ratio of the Emissions(in percent) in Russian Federation in 2003 to that in 2007?
Your response must be concise. 1.01. What is the ratio of the Emissions(in percent) of Seychelles in 2003 to that in 2007?
Your response must be concise. 1. What is the ratio of the Emissions(in percent) in Barbados in 2004 to that in 2005?
Make the answer very short. 1. What is the ratio of the Emissions(in percent) of Seychelles in 2004 to that in 2005?
Make the answer very short. 1. What is the ratio of the Emissions(in percent) of Israel in 2004 to that in 2006?
Offer a very short reply. 1.01. What is the ratio of the Emissions(in percent) of Russian Federation in 2004 to that in 2006?
Provide a succinct answer. 0.98. What is the ratio of the Emissions(in percent) in Seychelles in 2004 to that in 2006?
Keep it short and to the point. 1. What is the ratio of the Emissions(in percent) in Barbados in 2004 to that in 2007?
Your answer should be compact. 0.97. What is the ratio of the Emissions(in percent) of Israel in 2004 to that in 2007?
Provide a succinct answer. 1.04. What is the ratio of the Emissions(in percent) of Russian Federation in 2004 to that in 2007?
Give a very brief answer. 1. What is the ratio of the Emissions(in percent) in Barbados in 2005 to that in 2006?
Offer a very short reply. 1. What is the ratio of the Emissions(in percent) of Russian Federation in 2005 to that in 2006?
Your answer should be compact. 0.99. What is the ratio of the Emissions(in percent) of Barbados in 2005 to that in 2007?
Your response must be concise. 0.97. What is the ratio of the Emissions(in percent) of Israel in 2005 to that in 2007?
Your answer should be very brief. 1.03. What is the ratio of the Emissions(in percent) in Russian Federation in 2005 to that in 2007?
Give a very brief answer. 1.01. What is the ratio of the Emissions(in percent) of Seychelles in 2005 to that in 2007?
Make the answer very short. 1. What is the ratio of the Emissions(in percent) in Barbados in 2006 to that in 2007?
Provide a short and direct response. 0.97. What is the ratio of the Emissions(in percent) of Israel in 2006 to that in 2007?
Give a very brief answer. 1.03. What is the ratio of the Emissions(in percent) of Russian Federation in 2006 to that in 2007?
Ensure brevity in your answer.  1.02. What is the difference between the highest and the second highest Emissions(in percent) of Barbados?
Make the answer very short. 1.73. What is the difference between the highest and the second highest Emissions(in percent) in Israel?
Offer a very short reply. 0.84. What is the difference between the highest and the second highest Emissions(in percent) of Russian Federation?
Offer a terse response. 0.68. What is the difference between the highest and the lowest Emissions(in percent) of Barbados?
Make the answer very short. 3.13. What is the difference between the highest and the lowest Emissions(in percent) in Israel?
Make the answer very short. 8.96. What is the difference between the highest and the lowest Emissions(in percent) of Russian Federation?
Give a very brief answer. 1.12. What is the difference between the highest and the lowest Emissions(in percent) in Seychelles?
Ensure brevity in your answer.  0. 